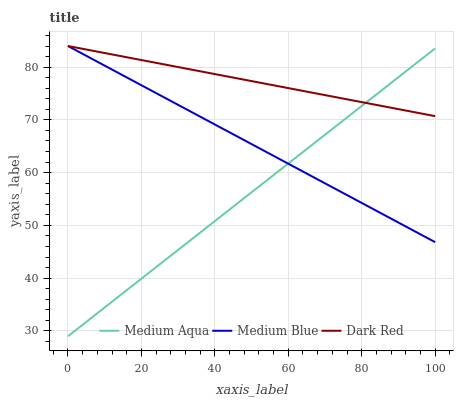Does Medium Aqua have the minimum area under the curve?
Answer yes or no. Yes. Does Dark Red have the maximum area under the curve?
Answer yes or no. Yes. Does Dark Red have the minimum area under the curve?
Answer yes or no. No. Does Medium Aqua have the maximum area under the curve?
Answer yes or no. No. Is Medium Blue the smoothest?
Answer yes or no. Yes. Is Medium Aqua the roughest?
Answer yes or no. Yes. Is Dark Red the smoothest?
Answer yes or no. No. Is Dark Red the roughest?
Answer yes or no. No. Does Medium Aqua have the lowest value?
Answer yes or no. Yes. Does Dark Red have the lowest value?
Answer yes or no. No. Does Dark Red have the highest value?
Answer yes or no. Yes. Does Medium Aqua have the highest value?
Answer yes or no. No. Does Dark Red intersect Medium Blue?
Answer yes or no. Yes. Is Dark Red less than Medium Blue?
Answer yes or no. No. Is Dark Red greater than Medium Blue?
Answer yes or no. No. 